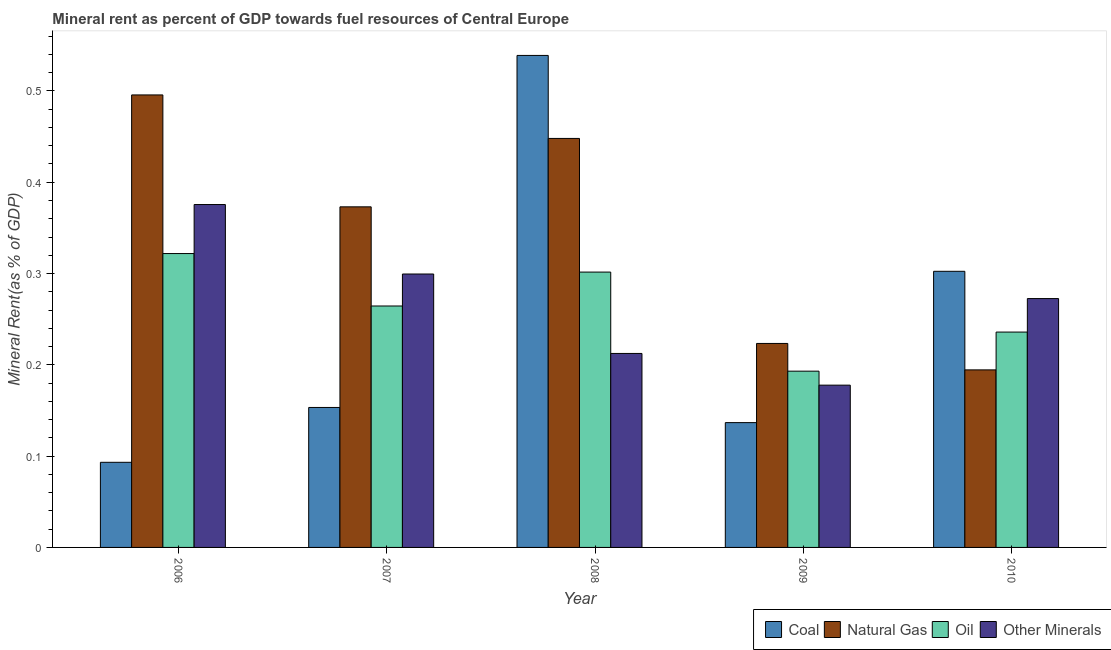How many different coloured bars are there?
Ensure brevity in your answer.  4. Are the number of bars on each tick of the X-axis equal?
Provide a short and direct response. Yes. How many bars are there on the 5th tick from the right?
Provide a succinct answer. 4. What is the label of the 4th group of bars from the left?
Provide a short and direct response. 2009. In how many cases, is the number of bars for a given year not equal to the number of legend labels?
Ensure brevity in your answer.  0. What is the natural gas rent in 2009?
Your response must be concise. 0.22. Across all years, what is the maximum coal rent?
Offer a terse response. 0.54. Across all years, what is the minimum coal rent?
Your answer should be compact. 0.09. In which year was the natural gas rent maximum?
Keep it short and to the point. 2006. In which year was the  rent of other minerals minimum?
Your answer should be very brief. 2009. What is the total  rent of other minerals in the graph?
Make the answer very short. 1.34. What is the difference between the oil rent in 2008 and that in 2009?
Your answer should be compact. 0.11. What is the difference between the coal rent in 2008 and the  rent of other minerals in 2007?
Offer a terse response. 0.39. What is the average oil rent per year?
Provide a short and direct response. 0.26. In the year 2006, what is the difference between the coal rent and oil rent?
Offer a very short reply. 0. In how many years, is the natural gas rent greater than 0.04 %?
Your answer should be compact. 5. What is the ratio of the oil rent in 2006 to that in 2008?
Offer a very short reply. 1.07. Is the difference between the  rent of other minerals in 2008 and 2010 greater than the difference between the oil rent in 2008 and 2010?
Ensure brevity in your answer.  No. What is the difference between the highest and the second highest natural gas rent?
Provide a succinct answer. 0.05. What is the difference between the highest and the lowest natural gas rent?
Offer a very short reply. 0.3. Is the sum of the coal rent in 2007 and 2009 greater than the maximum natural gas rent across all years?
Provide a short and direct response. No. Is it the case that in every year, the sum of the natural gas rent and oil rent is greater than the sum of coal rent and  rent of other minerals?
Keep it short and to the point. No. What does the 1st bar from the left in 2007 represents?
Offer a terse response. Coal. What does the 3rd bar from the right in 2010 represents?
Make the answer very short. Natural Gas. Is it the case that in every year, the sum of the coal rent and natural gas rent is greater than the oil rent?
Offer a terse response. Yes. Are all the bars in the graph horizontal?
Your answer should be very brief. No. How many years are there in the graph?
Give a very brief answer. 5. What is the difference between two consecutive major ticks on the Y-axis?
Provide a succinct answer. 0.1. Are the values on the major ticks of Y-axis written in scientific E-notation?
Make the answer very short. No. How many legend labels are there?
Provide a succinct answer. 4. What is the title of the graph?
Make the answer very short. Mineral rent as percent of GDP towards fuel resources of Central Europe. What is the label or title of the X-axis?
Provide a short and direct response. Year. What is the label or title of the Y-axis?
Provide a short and direct response. Mineral Rent(as % of GDP). What is the Mineral Rent(as % of GDP) of Coal in 2006?
Your response must be concise. 0.09. What is the Mineral Rent(as % of GDP) of Natural Gas in 2006?
Give a very brief answer. 0.5. What is the Mineral Rent(as % of GDP) in Oil in 2006?
Ensure brevity in your answer.  0.32. What is the Mineral Rent(as % of GDP) of Other Minerals in 2006?
Your response must be concise. 0.38. What is the Mineral Rent(as % of GDP) of Coal in 2007?
Offer a very short reply. 0.15. What is the Mineral Rent(as % of GDP) in Natural Gas in 2007?
Give a very brief answer. 0.37. What is the Mineral Rent(as % of GDP) in Oil in 2007?
Your response must be concise. 0.26. What is the Mineral Rent(as % of GDP) in Other Minerals in 2007?
Keep it short and to the point. 0.3. What is the Mineral Rent(as % of GDP) in Coal in 2008?
Offer a very short reply. 0.54. What is the Mineral Rent(as % of GDP) in Natural Gas in 2008?
Give a very brief answer. 0.45. What is the Mineral Rent(as % of GDP) of Oil in 2008?
Your answer should be very brief. 0.3. What is the Mineral Rent(as % of GDP) of Other Minerals in 2008?
Offer a terse response. 0.21. What is the Mineral Rent(as % of GDP) in Coal in 2009?
Your answer should be compact. 0.14. What is the Mineral Rent(as % of GDP) of Natural Gas in 2009?
Keep it short and to the point. 0.22. What is the Mineral Rent(as % of GDP) in Oil in 2009?
Your response must be concise. 0.19. What is the Mineral Rent(as % of GDP) in Other Minerals in 2009?
Ensure brevity in your answer.  0.18. What is the Mineral Rent(as % of GDP) in Coal in 2010?
Provide a succinct answer. 0.3. What is the Mineral Rent(as % of GDP) of Natural Gas in 2010?
Your answer should be compact. 0.19. What is the Mineral Rent(as % of GDP) in Oil in 2010?
Your answer should be very brief. 0.24. What is the Mineral Rent(as % of GDP) of Other Minerals in 2010?
Your answer should be very brief. 0.27. Across all years, what is the maximum Mineral Rent(as % of GDP) in Coal?
Make the answer very short. 0.54. Across all years, what is the maximum Mineral Rent(as % of GDP) of Natural Gas?
Provide a short and direct response. 0.5. Across all years, what is the maximum Mineral Rent(as % of GDP) in Oil?
Offer a very short reply. 0.32. Across all years, what is the maximum Mineral Rent(as % of GDP) of Other Minerals?
Your answer should be compact. 0.38. Across all years, what is the minimum Mineral Rent(as % of GDP) in Coal?
Your answer should be compact. 0.09. Across all years, what is the minimum Mineral Rent(as % of GDP) of Natural Gas?
Ensure brevity in your answer.  0.19. Across all years, what is the minimum Mineral Rent(as % of GDP) of Oil?
Offer a very short reply. 0.19. Across all years, what is the minimum Mineral Rent(as % of GDP) in Other Minerals?
Offer a terse response. 0.18. What is the total Mineral Rent(as % of GDP) in Coal in the graph?
Make the answer very short. 1.22. What is the total Mineral Rent(as % of GDP) of Natural Gas in the graph?
Ensure brevity in your answer.  1.73. What is the total Mineral Rent(as % of GDP) of Oil in the graph?
Ensure brevity in your answer.  1.32. What is the total Mineral Rent(as % of GDP) of Other Minerals in the graph?
Ensure brevity in your answer.  1.34. What is the difference between the Mineral Rent(as % of GDP) of Coal in 2006 and that in 2007?
Ensure brevity in your answer.  -0.06. What is the difference between the Mineral Rent(as % of GDP) of Natural Gas in 2006 and that in 2007?
Your answer should be very brief. 0.12. What is the difference between the Mineral Rent(as % of GDP) of Oil in 2006 and that in 2007?
Ensure brevity in your answer.  0.06. What is the difference between the Mineral Rent(as % of GDP) of Other Minerals in 2006 and that in 2007?
Your answer should be compact. 0.08. What is the difference between the Mineral Rent(as % of GDP) of Coal in 2006 and that in 2008?
Your response must be concise. -0.45. What is the difference between the Mineral Rent(as % of GDP) of Natural Gas in 2006 and that in 2008?
Give a very brief answer. 0.05. What is the difference between the Mineral Rent(as % of GDP) of Oil in 2006 and that in 2008?
Your answer should be very brief. 0.02. What is the difference between the Mineral Rent(as % of GDP) of Other Minerals in 2006 and that in 2008?
Your answer should be very brief. 0.16. What is the difference between the Mineral Rent(as % of GDP) of Coal in 2006 and that in 2009?
Ensure brevity in your answer.  -0.04. What is the difference between the Mineral Rent(as % of GDP) in Natural Gas in 2006 and that in 2009?
Your answer should be compact. 0.27. What is the difference between the Mineral Rent(as % of GDP) of Oil in 2006 and that in 2009?
Offer a terse response. 0.13. What is the difference between the Mineral Rent(as % of GDP) in Other Minerals in 2006 and that in 2009?
Ensure brevity in your answer.  0.2. What is the difference between the Mineral Rent(as % of GDP) in Coal in 2006 and that in 2010?
Your response must be concise. -0.21. What is the difference between the Mineral Rent(as % of GDP) in Natural Gas in 2006 and that in 2010?
Provide a short and direct response. 0.3. What is the difference between the Mineral Rent(as % of GDP) in Oil in 2006 and that in 2010?
Offer a very short reply. 0.09. What is the difference between the Mineral Rent(as % of GDP) in Other Minerals in 2006 and that in 2010?
Make the answer very short. 0.1. What is the difference between the Mineral Rent(as % of GDP) in Coal in 2007 and that in 2008?
Your answer should be very brief. -0.39. What is the difference between the Mineral Rent(as % of GDP) of Natural Gas in 2007 and that in 2008?
Your answer should be very brief. -0.07. What is the difference between the Mineral Rent(as % of GDP) of Oil in 2007 and that in 2008?
Your answer should be very brief. -0.04. What is the difference between the Mineral Rent(as % of GDP) of Other Minerals in 2007 and that in 2008?
Your answer should be very brief. 0.09. What is the difference between the Mineral Rent(as % of GDP) of Coal in 2007 and that in 2009?
Give a very brief answer. 0.02. What is the difference between the Mineral Rent(as % of GDP) in Natural Gas in 2007 and that in 2009?
Provide a succinct answer. 0.15. What is the difference between the Mineral Rent(as % of GDP) in Oil in 2007 and that in 2009?
Make the answer very short. 0.07. What is the difference between the Mineral Rent(as % of GDP) of Other Minerals in 2007 and that in 2009?
Your answer should be compact. 0.12. What is the difference between the Mineral Rent(as % of GDP) in Coal in 2007 and that in 2010?
Ensure brevity in your answer.  -0.15. What is the difference between the Mineral Rent(as % of GDP) of Natural Gas in 2007 and that in 2010?
Provide a short and direct response. 0.18. What is the difference between the Mineral Rent(as % of GDP) in Oil in 2007 and that in 2010?
Make the answer very short. 0.03. What is the difference between the Mineral Rent(as % of GDP) in Other Minerals in 2007 and that in 2010?
Give a very brief answer. 0.03. What is the difference between the Mineral Rent(as % of GDP) of Coal in 2008 and that in 2009?
Offer a very short reply. 0.4. What is the difference between the Mineral Rent(as % of GDP) in Natural Gas in 2008 and that in 2009?
Keep it short and to the point. 0.22. What is the difference between the Mineral Rent(as % of GDP) of Oil in 2008 and that in 2009?
Keep it short and to the point. 0.11. What is the difference between the Mineral Rent(as % of GDP) in Other Minerals in 2008 and that in 2009?
Give a very brief answer. 0.03. What is the difference between the Mineral Rent(as % of GDP) in Coal in 2008 and that in 2010?
Offer a very short reply. 0.24. What is the difference between the Mineral Rent(as % of GDP) of Natural Gas in 2008 and that in 2010?
Provide a succinct answer. 0.25. What is the difference between the Mineral Rent(as % of GDP) in Oil in 2008 and that in 2010?
Provide a short and direct response. 0.07. What is the difference between the Mineral Rent(as % of GDP) of Other Minerals in 2008 and that in 2010?
Provide a succinct answer. -0.06. What is the difference between the Mineral Rent(as % of GDP) in Coal in 2009 and that in 2010?
Make the answer very short. -0.17. What is the difference between the Mineral Rent(as % of GDP) in Natural Gas in 2009 and that in 2010?
Your response must be concise. 0.03. What is the difference between the Mineral Rent(as % of GDP) in Oil in 2009 and that in 2010?
Provide a succinct answer. -0.04. What is the difference between the Mineral Rent(as % of GDP) in Other Minerals in 2009 and that in 2010?
Offer a terse response. -0.09. What is the difference between the Mineral Rent(as % of GDP) in Coal in 2006 and the Mineral Rent(as % of GDP) in Natural Gas in 2007?
Your answer should be very brief. -0.28. What is the difference between the Mineral Rent(as % of GDP) of Coal in 2006 and the Mineral Rent(as % of GDP) of Oil in 2007?
Offer a terse response. -0.17. What is the difference between the Mineral Rent(as % of GDP) in Coal in 2006 and the Mineral Rent(as % of GDP) in Other Minerals in 2007?
Your answer should be compact. -0.21. What is the difference between the Mineral Rent(as % of GDP) in Natural Gas in 2006 and the Mineral Rent(as % of GDP) in Oil in 2007?
Provide a short and direct response. 0.23. What is the difference between the Mineral Rent(as % of GDP) of Natural Gas in 2006 and the Mineral Rent(as % of GDP) of Other Minerals in 2007?
Your answer should be very brief. 0.2. What is the difference between the Mineral Rent(as % of GDP) in Oil in 2006 and the Mineral Rent(as % of GDP) in Other Minerals in 2007?
Your answer should be very brief. 0.02. What is the difference between the Mineral Rent(as % of GDP) in Coal in 2006 and the Mineral Rent(as % of GDP) in Natural Gas in 2008?
Keep it short and to the point. -0.35. What is the difference between the Mineral Rent(as % of GDP) in Coal in 2006 and the Mineral Rent(as % of GDP) in Oil in 2008?
Keep it short and to the point. -0.21. What is the difference between the Mineral Rent(as % of GDP) in Coal in 2006 and the Mineral Rent(as % of GDP) in Other Minerals in 2008?
Offer a terse response. -0.12. What is the difference between the Mineral Rent(as % of GDP) in Natural Gas in 2006 and the Mineral Rent(as % of GDP) in Oil in 2008?
Your answer should be very brief. 0.19. What is the difference between the Mineral Rent(as % of GDP) of Natural Gas in 2006 and the Mineral Rent(as % of GDP) of Other Minerals in 2008?
Give a very brief answer. 0.28. What is the difference between the Mineral Rent(as % of GDP) of Oil in 2006 and the Mineral Rent(as % of GDP) of Other Minerals in 2008?
Your answer should be very brief. 0.11. What is the difference between the Mineral Rent(as % of GDP) in Coal in 2006 and the Mineral Rent(as % of GDP) in Natural Gas in 2009?
Offer a terse response. -0.13. What is the difference between the Mineral Rent(as % of GDP) of Coal in 2006 and the Mineral Rent(as % of GDP) of Oil in 2009?
Make the answer very short. -0.1. What is the difference between the Mineral Rent(as % of GDP) of Coal in 2006 and the Mineral Rent(as % of GDP) of Other Minerals in 2009?
Your answer should be compact. -0.08. What is the difference between the Mineral Rent(as % of GDP) in Natural Gas in 2006 and the Mineral Rent(as % of GDP) in Oil in 2009?
Give a very brief answer. 0.3. What is the difference between the Mineral Rent(as % of GDP) in Natural Gas in 2006 and the Mineral Rent(as % of GDP) in Other Minerals in 2009?
Provide a succinct answer. 0.32. What is the difference between the Mineral Rent(as % of GDP) in Oil in 2006 and the Mineral Rent(as % of GDP) in Other Minerals in 2009?
Your answer should be very brief. 0.14. What is the difference between the Mineral Rent(as % of GDP) of Coal in 2006 and the Mineral Rent(as % of GDP) of Natural Gas in 2010?
Make the answer very short. -0.1. What is the difference between the Mineral Rent(as % of GDP) in Coal in 2006 and the Mineral Rent(as % of GDP) in Oil in 2010?
Your answer should be compact. -0.14. What is the difference between the Mineral Rent(as % of GDP) in Coal in 2006 and the Mineral Rent(as % of GDP) in Other Minerals in 2010?
Make the answer very short. -0.18. What is the difference between the Mineral Rent(as % of GDP) in Natural Gas in 2006 and the Mineral Rent(as % of GDP) in Oil in 2010?
Keep it short and to the point. 0.26. What is the difference between the Mineral Rent(as % of GDP) of Natural Gas in 2006 and the Mineral Rent(as % of GDP) of Other Minerals in 2010?
Your answer should be compact. 0.22. What is the difference between the Mineral Rent(as % of GDP) in Oil in 2006 and the Mineral Rent(as % of GDP) in Other Minerals in 2010?
Offer a very short reply. 0.05. What is the difference between the Mineral Rent(as % of GDP) in Coal in 2007 and the Mineral Rent(as % of GDP) in Natural Gas in 2008?
Make the answer very short. -0.29. What is the difference between the Mineral Rent(as % of GDP) of Coal in 2007 and the Mineral Rent(as % of GDP) of Oil in 2008?
Your response must be concise. -0.15. What is the difference between the Mineral Rent(as % of GDP) in Coal in 2007 and the Mineral Rent(as % of GDP) in Other Minerals in 2008?
Ensure brevity in your answer.  -0.06. What is the difference between the Mineral Rent(as % of GDP) of Natural Gas in 2007 and the Mineral Rent(as % of GDP) of Oil in 2008?
Keep it short and to the point. 0.07. What is the difference between the Mineral Rent(as % of GDP) of Natural Gas in 2007 and the Mineral Rent(as % of GDP) of Other Minerals in 2008?
Your answer should be very brief. 0.16. What is the difference between the Mineral Rent(as % of GDP) of Oil in 2007 and the Mineral Rent(as % of GDP) of Other Minerals in 2008?
Your answer should be very brief. 0.05. What is the difference between the Mineral Rent(as % of GDP) in Coal in 2007 and the Mineral Rent(as % of GDP) in Natural Gas in 2009?
Your response must be concise. -0.07. What is the difference between the Mineral Rent(as % of GDP) of Coal in 2007 and the Mineral Rent(as % of GDP) of Oil in 2009?
Keep it short and to the point. -0.04. What is the difference between the Mineral Rent(as % of GDP) of Coal in 2007 and the Mineral Rent(as % of GDP) of Other Minerals in 2009?
Your answer should be very brief. -0.02. What is the difference between the Mineral Rent(as % of GDP) in Natural Gas in 2007 and the Mineral Rent(as % of GDP) in Oil in 2009?
Keep it short and to the point. 0.18. What is the difference between the Mineral Rent(as % of GDP) in Natural Gas in 2007 and the Mineral Rent(as % of GDP) in Other Minerals in 2009?
Provide a short and direct response. 0.2. What is the difference between the Mineral Rent(as % of GDP) in Oil in 2007 and the Mineral Rent(as % of GDP) in Other Minerals in 2009?
Your answer should be very brief. 0.09. What is the difference between the Mineral Rent(as % of GDP) in Coal in 2007 and the Mineral Rent(as % of GDP) in Natural Gas in 2010?
Offer a very short reply. -0.04. What is the difference between the Mineral Rent(as % of GDP) in Coal in 2007 and the Mineral Rent(as % of GDP) in Oil in 2010?
Provide a succinct answer. -0.08. What is the difference between the Mineral Rent(as % of GDP) of Coal in 2007 and the Mineral Rent(as % of GDP) of Other Minerals in 2010?
Make the answer very short. -0.12. What is the difference between the Mineral Rent(as % of GDP) of Natural Gas in 2007 and the Mineral Rent(as % of GDP) of Oil in 2010?
Provide a succinct answer. 0.14. What is the difference between the Mineral Rent(as % of GDP) of Natural Gas in 2007 and the Mineral Rent(as % of GDP) of Other Minerals in 2010?
Provide a succinct answer. 0.1. What is the difference between the Mineral Rent(as % of GDP) in Oil in 2007 and the Mineral Rent(as % of GDP) in Other Minerals in 2010?
Provide a succinct answer. -0.01. What is the difference between the Mineral Rent(as % of GDP) in Coal in 2008 and the Mineral Rent(as % of GDP) in Natural Gas in 2009?
Provide a short and direct response. 0.32. What is the difference between the Mineral Rent(as % of GDP) in Coal in 2008 and the Mineral Rent(as % of GDP) in Oil in 2009?
Ensure brevity in your answer.  0.35. What is the difference between the Mineral Rent(as % of GDP) of Coal in 2008 and the Mineral Rent(as % of GDP) of Other Minerals in 2009?
Keep it short and to the point. 0.36. What is the difference between the Mineral Rent(as % of GDP) of Natural Gas in 2008 and the Mineral Rent(as % of GDP) of Oil in 2009?
Keep it short and to the point. 0.25. What is the difference between the Mineral Rent(as % of GDP) in Natural Gas in 2008 and the Mineral Rent(as % of GDP) in Other Minerals in 2009?
Offer a terse response. 0.27. What is the difference between the Mineral Rent(as % of GDP) in Oil in 2008 and the Mineral Rent(as % of GDP) in Other Minerals in 2009?
Your answer should be very brief. 0.12. What is the difference between the Mineral Rent(as % of GDP) of Coal in 2008 and the Mineral Rent(as % of GDP) of Natural Gas in 2010?
Keep it short and to the point. 0.34. What is the difference between the Mineral Rent(as % of GDP) in Coal in 2008 and the Mineral Rent(as % of GDP) in Oil in 2010?
Provide a succinct answer. 0.3. What is the difference between the Mineral Rent(as % of GDP) in Coal in 2008 and the Mineral Rent(as % of GDP) in Other Minerals in 2010?
Your response must be concise. 0.27. What is the difference between the Mineral Rent(as % of GDP) of Natural Gas in 2008 and the Mineral Rent(as % of GDP) of Oil in 2010?
Provide a short and direct response. 0.21. What is the difference between the Mineral Rent(as % of GDP) in Natural Gas in 2008 and the Mineral Rent(as % of GDP) in Other Minerals in 2010?
Your answer should be very brief. 0.18. What is the difference between the Mineral Rent(as % of GDP) in Oil in 2008 and the Mineral Rent(as % of GDP) in Other Minerals in 2010?
Give a very brief answer. 0.03. What is the difference between the Mineral Rent(as % of GDP) in Coal in 2009 and the Mineral Rent(as % of GDP) in Natural Gas in 2010?
Keep it short and to the point. -0.06. What is the difference between the Mineral Rent(as % of GDP) in Coal in 2009 and the Mineral Rent(as % of GDP) in Oil in 2010?
Give a very brief answer. -0.1. What is the difference between the Mineral Rent(as % of GDP) in Coal in 2009 and the Mineral Rent(as % of GDP) in Other Minerals in 2010?
Give a very brief answer. -0.14. What is the difference between the Mineral Rent(as % of GDP) of Natural Gas in 2009 and the Mineral Rent(as % of GDP) of Oil in 2010?
Provide a succinct answer. -0.01. What is the difference between the Mineral Rent(as % of GDP) in Natural Gas in 2009 and the Mineral Rent(as % of GDP) in Other Minerals in 2010?
Provide a succinct answer. -0.05. What is the difference between the Mineral Rent(as % of GDP) of Oil in 2009 and the Mineral Rent(as % of GDP) of Other Minerals in 2010?
Keep it short and to the point. -0.08. What is the average Mineral Rent(as % of GDP) of Coal per year?
Your answer should be very brief. 0.24. What is the average Mineral Rent(as % of GDP) in Natural Gas per year?
Offer a very short reply. 0.35. What is the average Mineral Rent(as % of GDP) of Oil per year?
Offer a very short reply. 0.26. What is the average Mineral Rent(as % of GDP) of Other Minerals per year?
Offer a very short reply. 0.27. In the year 2006, what is the difference between the Mineral Rent(as % of GDP) in Coal and Mineral Rent(as % of GDP) in Natural Gas?
Keep it short and to the point. -0.4. In the year 2006, what is the difference between the Mineral Rent(as % of GDP) in Coal and Mineral Rent(as % of GDP) in Oil?
Offer a terse response. -0.23. In the year 2006, what is the difference between the Mineral Rent(as % of GDP) in Coal and Mineral Rent(as % of GDP) in Other Minerals?
Provide a succinct answer. -0.28. In the year 2006, what is the difference between the Mineral Rent(as % of GDP) of Natural Gas and Mineral Rent(as % of GDP) of Oil?
Provide a succinct answer. 0.17. In the year 2006, what is the difference between the Mineral Rent(as % of GDP) of Natural Gas and Mineral Rent(as % of GDP) of Other Minerals?
Ensure brevity in your answer.  0.12. In the year 2006, what is the difference between the Mineral Rent(as % of GDP) of Oil and Mineral Rent(as % of GDP) of Other Minerals?
Provide a short and direct response. -0.05. In the year 2007, what is the difference between the Mineral Rent(as % of GDP) in Coal and Mineral Rent(as % of GDP) in Natural Gas?
Offer a terse response. -0.22. In the year 2007, what is the difference between the Mineral Rent(as % of GDP) of Coal and Mineral Rent(as % of GDP) of Oil?
Give a very brief answer. -0.11. In the year 2007, what is the difference between the Mineral Rent(as % of GDP) of Coal and Mineral Rent(as % of GDP) of Other Minerals?
Offer a very short reply. -0.15. In the year 2007, what is the difference between the Mineral Rent(as % of GDP) in Natural Gas and Mineral Rent(as % of GDP) in Oil?
Provide a succinct answer. 0.11. In the year 2007, what is the difference between the Mineral Rent(as % of GDP) of Natural Gas and Mineral Rent(as % of GDP) of Other Minerals?
Offer a very short reply. 0.07. In the year 2007, what is the difference between the Mineral Rent(as % of GDP) in Oil and Mineral Rent(as % of GDP) in Other Minerals?
Make the answer very short. -0.04. In the year 2008, what is the difference between the Mineral Rent(as % of GDP) of Coal and Mineral Rent(as % of GDP) of Natural Gas?
Keep it short and to the point. 0.09. In the year 2008, what is the difference between the Mineral Rent(as % of GDP) of Coal and Mineral Rent(as % of GDP) of Oil?
Your response must be concise. 0.24. In the year 2008, what is the difference between the Mineral Rent(as % of GDP) of Coal and Mineral Rent(as % of GDP) of Other Minerals?
Offer a very short reply. 0.33. In the year 2008, what is the difference between the Mineral Rent(as % of GDP) in Natural Gas and Mineral Rent(as % of GDP) in Oil?
Your answer should be compact. 0.15. In the year 2008, what is the difference between the Mineral Rent(as % of GDP) in Natural Gas and Mineral Rent(as % of GDP) in Other Minerals?
Your answer should be compact. 0.24. In the year 2008, what is the difference between the Mineral Rent(as % of GDP) of Oil and Mineral Rent(as % of GDP) of Other Minerals?
Offer a very short reply. 0.09. In the year 2009, what is the difference between the Mineral Rent(as % of GDP) in Coal and Mineral Rent(as % of GDP) in Natural Gas?
Provide a short and direct response. -0.09. In the year 2009, what is the difference between the Mineral Rent(as % of GDP) in Coal and Mineral Rent(as % of GDP) in Oil?
Offer a very short reply. -0.06. In the year 2009, what is the difference between the Mineral Rent(as % of GDP) of Coal and Mineral Rent(as % of GDP) of Other Minerals?
Your answer should be compact. -0.04. In the year 2009, what is the difference between the Mineral Rent(as % of GDP) of Natural Gas and Mineral Rent(as % of GDP) of Oil?
Offer a very short reply. 0.03. In the year 2009, what is the difference between the Mineral Rent(as % of GDP) in Natural Gas and Mineral Rent(as % of GDP) in Other Minerals?
Your answer should be compact. 0.05. In the year 2009, what is the difference between the Mineral Rent(as % of GDP) in Oil and Mineral Rent(as % of GDP) in Other Minerals?
Your response must be concise. 0.02. In the year 2010, what is the difference between the Mineral Rent(as % of GDP) of Coal and Mineral Rent(as % of GDP) of Natural Gas?
Ensure brevity in your answer.  0.11. In the year 2010, what is the difference between the Mineral Rent(as % of GDP) of Coal and Mineral Rent(as % of GDP) of Oil?
Your answer should be compact. 0.07. In the year 2010, what is the difference between the Mineral Rent(as % of GDP) of Coal and Mineral Rent(as % of GDP) of Other Minerals?
Provide a succinct answer. 0.03. In the year 2010, what is the difference between the Mineral Rent(as % of GDP) in Natural Gas and Mineral Rent(as % of GDP) in Oil?
Your answer should be very brief. -0.04. In the year 2010, what is the difference between the Mineral Rent(as % of GDP) in Natural Gas and Mineral Rent(as % of GDP) in Other Minerals?
Offer a very short reply. -0.08. In the year 2010, what is the difference between the Mineral Rent(as % of GDP) in Oil and Mineral Rent(as % of GDP) in Other Minerals?
Offer a terse response. -0.04. What is the ratio of the Mineral Rent(as % of GDP) in Coal in 2006 to that in 2007?
Provide a succinct answer. 0.61. What is the ratio of the Mineral Rent(as % of GDP) in Natural Gas in 2006 to that in 2007?
Provide a succinct answer. 1.33. What is the ratio of the Mineral Rent(as % of GDP) of Oil in 2006 to that in 2007?
Your answer should be compact. 1.22. What is the ratio of the Mineral Rent(as % of GDP) of Other Minerals in 2006 to that in 2007?
Your answer should be very brief. 1.25. What is the ratio of the Mineral Rent(as % of GDP) in Coal in 2006 to that in 2008?
Your answer should be very brief. 0.17. What is the ratio of the Mineral Rent(as % of GDP) in Natural Gas in 2006 to that in 2008?
Your answer should be compact. 1.11. What is the ratio of the Mineral Rent(as % of GDP) in Oil in 2006 to that in 2008?
Offer a terse response. 1.07. What is the ratio of the Mineral Rent(as % of GDP) in Other Minerals in 2006 to that in 2008?
Provide a short and direct response. 1.77. What is the ratio of the Mineral Rent(as % of GDP) in Coal in 2006 to that in 2009?
Provide a succinct answer. 0.68. What is the ratio of the Mineral Rent(as % of GDP) of Natural Gas in 2006 to that in 2009?
Your answer should be very brief. 2.22. What is the ratio of the Mineral Rent(as % of GDP) in Oil in 2006 to that in 2009?
Your answer should be very brief. 1.67. What is the ratio of the Mineral Rent(as % of GDP) in Other Minerals in 2006 to that in 2009?
Ensure brevity in your answer.  2.11. What is the ratio of the Mineral Rent(as % of GDP) of Coal in 2006 to that in 2010?
Your response must be concise. 0.31. What is the ratio of the Mineral Rent(as % of GDP) in Natural Gas in 2006 to that in 2010?
Provide a short and direct response. 2.55. What is the ratio of the Mineral Rent(as % of GDP) in Oil in 2006 to that in 2010?
Your answer should be compact. 1.36. What is the ratio of the Mineral Rent(as % of GDP) in Other Minerals in 2006 to that in 2010?
Your answer should be very brief. 1.38. What is the ratio of the Mineral Rent(as % of GDP) of Coal in 2007 to that in 2008?
Offer a very short reply. 0.28. What is the ratio of the Mineral Rent(as % of GDP) in Natural Gas in 2007 to that in 2008?
Keep it short and to the point. 0.83. What is the ratio of the Mineral Rent(as % of GDP) in Oil in 2007 to that in 2008?
Offer a very short reply. 0.88. What is the ratio of the Mineral Rent(as % of GDP) in Other Minerals in 2007 to that in 2008?
Ensure brevity in your answer.  1.41. What is the ratio of the Mineral Rent(as % of GDP) in Coal in 2007 to that in 2009?
Give a very brief answer. 1.12. What is the ratio of the Mineral Rent(as % of GDP) of Natural Gas in 2007 to that in 2009?
Your response must be concise. 1.67. What is the ratio of the Mineral Rent(as % of GDP) of Oil in 2007 to that in 2009?
Your answer should be compact. 1.37. What is the ratio of the Mineral Rent(as % of GDP) in Other Minerals in 2007 to that in 2009?
Make the answer very short. 1.68. What is the ratio of the Mineral Rent(as % of GDP) of Coal in 2007 to that in 2010?
Give a very brief answer. 0.51. What is the ratio of the Mineral Rent(as % of GDP) in Natural Gas in 2007 to that in 2010?
Offer a very short reply. 1.92. What is the ratio of the Mineral Rent(as % of GDP) in Oil in 2007 to that in 2010?
Give a very brief answer. 1.12. What is the ratio of the Mineral Rent(as % of GDP) of Other Minerals in 2007 to that in 2010?
Your answer should be compact. 1.1. What is the ratio of the Mineral Rent(as % of GDP) in Coal in 2008 to that in 2009?
Your answer should be compact. 3.94. What is the ratio of the Mineral Rent(as % of GDP) of Natural Gas in 2008 to that in 2009?
Provide a succinct answer. 2.01. What is the ratio of the Mineral Rent(as % of GDP) in Oil in 2008 to that in 2009?
Your response must be concise. 1.56. What is the ratio of the Mineral Rent(as % of GDP) in Other Minerals in 2008 to that in 2009?
Keep it short and to the point. 1.2. What is the ratio of the Mineral Rent(as % of GDP) in Coal in 2008 to that in 2010?
Provide a succinct answer. 1.78. What is the ratio of the Mineral Rent(as % of GDP) of Natural Gas in 2008 to that in 2010?
Provide a succinct answer. 2.3. What is the ratio of the Mineral Rent(as % of GDP) in Oil in 2008 to that in 2010?
Keep it short and to the point. 1.28. What is the ratio of the Mineral Rent(as % of GDP) of Other Minerals in 2008 to that in 2010?
Keep it short and to the point. 0.78. What is the ratio of the Mineral Rent(as % of GDP) of Coal in 2009 to that in 2010?
Provide a short and direct response. 0.45. What is the ratio of the Mineral Rent(as % of GDP) of Natural Gas in 2009 to that in 2010?
Give a very brief answer. 1.15. What is the ratio of the Mineral Rent(as % of GDP) of Oil in 2009 to that in 2010?
Keep it short and to the point. 0.82. What is the ratio of the Mineral Rent(as % of GDP) in Other Minerals in 2009 to that in 2010?
Give a very brief answer. 0.65. What is the difference between the highest and the second highest Mineral Rent(as % of GDP) in Coal?
Your answer should be very brief. 0.24. What is the difference between the highest and the second highest Mineral Rent(as % of GDP) in Natural Gas?
Provide a short and direct response. 0.05. What is the difference between the highest and the second highest Mineral Rent(as % of GDP) in Oil?
Offer a terse response. 0.02. What is the difference between the highest and the second highest Mineral Rent(as % of GDP) in Other Minerals?
Provide a succinct answer. 0.08. What is the difference between the highest and the lowest Mineral Rent(as % of GDP) in Coal?
Provide a short and direct response. 0.45. What is the difference between the highest and the lowest Mineral Rent(as % of GDP) in Natural Gas?
Give a very brief answer. 0.3. What is the difference between the highest and the lowest Mineral Rent(as % of GDP) in Oil?
Provide a succinct answer. 0.13. What is the difference between the highest and the lowest Mineral Rent(as % of GDP) in Other Minerals?
Your response must be concise. 0.2. 